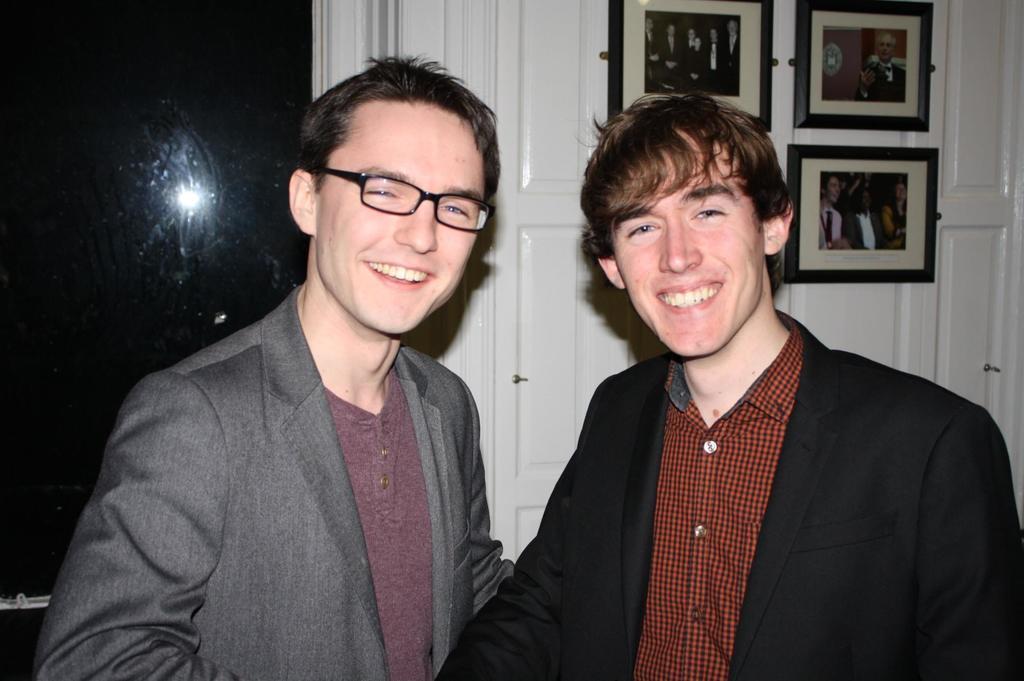Could you give a brief overview of what you see in this image? The man in the brown shirt and black blazer is standing and he is smiling. Beside him, the man in grey blazer who is wearing the spectacles is standing and he is also smiling. Behind them, we see a white wall or a cupboard on which photo frames are placed. On the left side, it is black in color and it might be a glass window. 